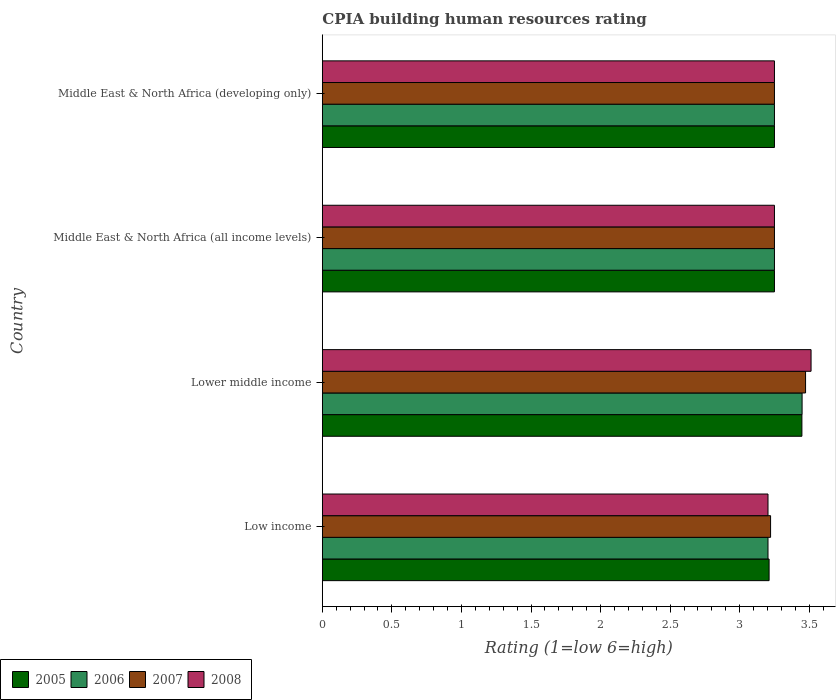How many different coloured bars are there?
Make the answer very short. 4. How many groups of bars are there?
Keep it short and to the point. 4. Are the number of bars per tick equal to the number of legend labels?
Your response must be concise. Yes. Are the number of bars on each tick of the Y-axis equal?
Ensure brevity in your answer.  Yes. How many bars are there on the 1st tick from the top?
Offer a terse response. 4. What is the label of the 1st group of bars from the top?
Your answer should be very brief. Middle East & North Africa (developing only). Across all countries, what is the maximum CPIA rating in 2007?
Your answer should be compact. 3.47. Across all countries, what is the minimum CPIA rating in 2007?
Make the answer very short. 3.22. In which country was the CPIA rating in 2006 maximum?
Your answer should be very brief. Lower middle income. In which country was the CPIA rating in 2008 minimum?
Provide a succinct answer. Low income. What is the total CPIA rating in 2005 in the graph?
Provide a short and direct response. 13.16. What is the difference between the CPIA rating in 2007 in Lower middle income and that in Middle East & North Africa (developing only)?
Offer a very short reply. 0.22. What is the difference between the CPIA rating in 2007 in Middle East & North Africa (all income levels) and the CPIA rating in 2006 in Low income?
Offer a very short reply. 0.05. What is the average CPIA rating in 2007 per country?
Keep it short and to the point. 3.3. What is the difference between the CPIA rating in 2006 and CPIA rating in 2007 in Middle East & North Africa (developing only)?
Provide a short and direct response. 0. In how many countries, is the CPIA rating in 2007 greater than 0.6 ?
Your answer should be compact. 4. What is the ratio of the CPIA rating in 2005 in Lower middle income to that in Middle East & North Africa (developing only)?
Provide a short and direct response. 1.06. Is the difference between the CPIA rating in 2006 in Low income and Middle East & North Africa (developing only) greater than the difference between the CPIA rating in 2007 in Low income and Middle East & North Africa (developing only)?
Provide a succinct answer. No. What is the difference between the highest and the second highest CPIA rating in 2005?
Offer a terse response. 0.2. What is the difference between the highest and the lowest CPIA rating in 2008?
Your response must be concise. 0.31. In how many countries, is the CPIA rating in 2007 greater than the average CPIA rating in 2007 taken over all countries?
Your response must be concise. 1. What does the 2nd bar from the top in Lower middle income represents?
Provide a succinct answer. 2007. Is it the case that in every country, the sum of the CPIA rating in 2008 and CPIA rating in 2006 is greater than the CPIA rating in 2005?
Offer a terse response. Yes. How many bars are there?
Ensure brevity in your answer.  16. What is the difference between two consecutive major ticks on the X-axis?
Provide a succinct answer. 0.5. Are the values on the major ticks of X-axis written in scientific E-notation?
Provide a succinct answer. No. Does the graph contain grids?
Make the answer very short. No. What is the title of the graph?
Your response must be concise. CPIA building human resources rating. Does "2009" appear as one of the legend labels in the graph?
Your response must be concise. No. What is the label or title of the X-axis?
Keep it short and to the point. Rating (1=low 6=high). What is the Rating (1=low 6=high) in 2005 in Low income?
Offer a terse response. 3.21. What is the Rating (1=low 6=high) of 2006 in Low income?
Provide a short and direct response. 3.2. What is the Rating (1=low 6=high) of 2007 in Low income?
Keep it short and to the point. 3.22. What is the Rating (1=low 6=high) in 2008 in Low income?
Offer a terse response. 3.2. What is the Rating (1=low 6=high) of 2005 in Lower middle income?
Offer a terse response. 3.45. What is the Rating (1=low 6=high) in 2006 in Lower middle income?
Offer a terse response. 3.45. What is the Rating (1=low 6=high) of 2007 in Lower middle income?
Offer a very short reply. 3.47. What is the Rating (1=low 6=high) in 2008 in Lower middle income?
Your response must be concise. 3.51. What is the Rating (1=low 6=high) of 2007 in Middle East & North Africa (developing only)?
Make the answer very short. 3.25. Across all countries, what is the maximum Rating (1=low 6=high) of 2005?
Provide a short and direct response. 3.45. Across all countries, what is the maximum Rating (1=low 6=high) in 2006?
Provide a short and direct response. 3.45. Across all countries, what is the maximum Rating (1=low 6=high) in 2007?
Offer a very short reply. 3.47. Across all countries, what is the maximum Rating (1=low 6=high) of 2008?
Your answer should be compact. 3.51. Across all countries, what is the minimum Rating (1=low 6=high) of 2005?
Keep it short and to the point. 3.21. Across all countries, what is the minimum Rating (1=low 6=high) in 2006?
Provide a succinct answer. 3.2. Across all countries, what is the minimum Rating (1=low 6=high) of 2007?
Ensure brevity in your answer.  3.22. Across all countries, what is the minimum Rating (1=low 6=high) in 2008?
Offer a terse response. 3.2. What is the total Rating (1=low 6=high) in 2005 in the graph?
Provide a short and direct response. 13.16. What is the total Rating (1=low 6=high) of 2006 in the graph?
Offer a terse response. 13.15. What is the total Rating (1=low 6=high) in 2007 in the graph?
Your answer should be compact. 13.2. What is the total Rating (1=low 6=high) of 2008 in the graph?
Your answer should be compact. 13.22. What is the difference between the Rating (1=low 6=high) of 2005 in Low income and that in Lower middle income?
Offer a terse response. -0.24. What is the difference between the Rating (1=low 6=high) of 2006 in Low income and that in Lower middle income?
Make the answer very short. -0.24. What is the difference between the Rating (1=low 6=high) of 2007 in Low income and that in Lower middle income?
Your answer should be compact. -0.25. What is the difference between the Rating (1=low 6=high) in 2008 in Low income and that in Lower middle income?
Give a very brief answer. -0.31. What is the difference between the Rating (1=low 6=high) in 2005 in Low income and that in Middle East & North Africa (all income levels)?
Your response must be concise. -0.04. What is the difference between the Rating (1=low 6=high) in 2006 in Low income and that in Middle East & North Africa (all income levels)?
Make the answer very short. -0.05. What is the difference between the Rating (1=low 6=high) in 2007 in Low income and that in Middle East & North Africa (all income levels)?
Your answer should be compact. -0.03. What is the difference between the Rating (1=low 6=high) of 2008 in Low income and that in Middle East & North Africa (all income levels)?
Provide a succinct answer. -0.05. What is the difference between the Rating (1=low 6=high) in 2005 in Low income and that in Middle East & North Africa (developing only)?
Your answer should be compact. -0.04. What is the difference between the Rating (1=low 6=high) of 2006 in Low income and that in Middle East & North Africa (developing only)?
Provide a short and direct response. -0.05. What is the difference between the Rating (1=low 6=high) in 2007 in Low income and that in Middle East & North Africa (developing only)?
Ensure brevity in your answer.  -0.03. What is the difference between the Rating (1=low 6=high) of 2008 in Low income and that in Middle East & North Africa (developing only)?
Your answer should be very brief. -0.05. What is the difference between the Rating (1=low 6=high) of 2005 in Lower middle income and that in Middle East & North Africa (all income levels)?
Your answer should be very brief. 0.2. What is the difference between the Rating (1=low 6=high) of 2006 in Lower middle income and that in Middle East & North Africa (all income levels)?
Your answer should be very brief. 0.2. What is the difference between the Rating (1=low 6=high) of 2007 in Lower middle income and that in Middle East & North Africa (all income levels)?
Your response must be concise. 0.22. What is the difference between the Rating (1=low 6=high) of 2008 in Lower middle income and that in Middle East & North Africa (all income levels)?
Offer a terse response. 0.26. What is the difference between the Rating (1=low 6=high) of 2005 in Lower middle income and that in Middle East & North Africa (developing only)?
Offer a terse response. 0.2. What is the difference between the Rating (1=low 6=high) of 2006 in Lower middle income and that in Middle East & North Africa (developing only)?
Your answer should be very brief. 0.2. What is the difference between the Rating (1=low 6=high) in 2007 in Lower middle income and that in Middle East & North Africa (developing only)?
Give a very brief answer. 0.22. What is the difference between the Rating (1=low 6=high) of 2008 in Lower middle income and that in Middle East & North Africa (developing only)?
Keep it short and to the point. 0.26. What is the difference between the Rating (1=low 6=high) of 2005 in Middle East & North Africa (all income levels) and that in Middle East & North Africa (developing only)?
Provide a succinct answer. 0. What is the difference between the Rating (1=low 6=high) of 2006 in Middle East & North Africa (all income levels) and that in Middle East & North Africa (developing only)?
Your answer should be very brief. 0. What is the difference between the Rating (1=low 6=high) in 2007 in Middle East & North Africa (all income levels) and that in Middle East & North Africa (developing only)?
Give a very brief answer. 0. What is the difference between the Rating (1=low 6=high) in 2005 in Low income and the Rating (1=low 6=high) in 2006 in Lower middle income?
Your answer should be very brief. -0.24. What is the difference between the Rating (1=low 6=high) in 2005 in Low income and the Rating (1=low 6=high) in 2007 in Lower middle income?
Provide a succinct answer. -0.26. What is the difference between the Rating (1=low 6=high) of 2005 in Low income and the Rating (1=low 6=high) of 2008 in Lower middle income?
Your response must be concise. -0.3. What is the difference between the Rating (1=low 6=high) of 2006 in Low income and the Rating (1=low 6=high) of 2007 in Lower middle income?
Offer a terse response. -0.27. What is the difference between the Rating (1=low 6=high) in 2006 in Low income and the Rating (1=low 6=high) in 2008 in Lower middle income?
Keep it short and to the point. -0.31. What is the difference between the Rating (1=low 6=high) of 2007 in Low income and the Rating (1=low 6=high) of 2008 in Lower middle income?
Provide a short and direct response. -0.29. What is the difference between the Rating (1=low 6=high) in 2005 in Low income and the Rating (1=low 6=high) in 2006 in Middle East & North Africa (all income levels)?
Make the answer very short. -0.04. What is the difference between the Rating (1=low 6=high) in 2005 in Low income and the Rating (1=low 6=high) in 2007 in Middle East & North Africa (all income levels)?
Your answer should be compact. -0.04. What is the difference between the Rating (1=low 6=high) of 2005 in Low income and the Rating (1=low 6=high) of 2008 in Middle East & North Africa (all income levels)?
Your answer should be very brief. -0.04. What is the difference between the Rating (1=low 6=high) of 2006 in Low income and the Rating (1=low 6=high) of 2007 in Middle East & North Africa (all income levels)?
Offer a very short reply. -0.05. What is the difference between the Rating (1=low 6=high) in 2006 in Low income and the Rating (1=low 6=high) in 2008 in Middle East & North Africa (all income levels)?
Your answer should be compact. -0.05. What is the difference between the Rating (1=low 6=high) in 2007 in Low income and the Rating (1=low 6=high) in 2008 in Middle East & North Africa (all income levels)?
Make the answer very short. -0.03. What is the difference between the Rating (1=low 6=high) in 2005 in Low income and the Rating (1=low 6=high) in 2006 in Middle East & North Africa (developing only)?
Provide a succinct answer. -0.04. What is the difference between the Rating (1=low 6=high) of 2005 in Low income and the Rating (1=low 6=high) of 2007 in Middle East & North Africa (developing only)?
Your response must be concise. -0.04. What is the difference between the Rating (1=low 6=high) of 2005 in Low income and the Rating (1=low 6=high) of 2008 in Middle East & North Africa (developing only)?
Provide a short and direct response. -0.04. What is the difference between the Rating (1=low 6=high) in 2006 in Low income and the Rating (1=low 6=high) in 2007 in Middle East & North Africa (developing only)?
Your response must be concise. -0.05. What is the difference between the Rating (1=low 6=high) in 2006 in Low income and the Rating (1=low 6=high) in 2008 in Middle East & North Africa (developing only)?
Ensure brevity in your answer.  -0.05. What is the difference between the Rating (1=low 6=high) of 2007 in Low income and the Rating (1=low 6=high) of 2008 in Middle East & North Africa (developing only)?
Offer a very short reply. -0.03. What is the difference between the Rating (1=low 6=high) of 2005 in Lower middle income and the Rating (1=low 6=high) of 2006 in Middle East & North Africa (all income levels)?
Provide a short and direct response. 0.2. What is the difference between the Rating (1=low 6=high) in 2005 in Lower middle income and the Rating (1=low 6=high) in 2007 in Middle East & North Africa (all income levels)?
Your answer should be very brief. 0.2. What is the difference between the Rating (1=low 6=high) in 2005 in Lower middle income and the Rating (1=low 6=high) in 2008 in Middle East & North Africa (all income levels)?
Provide a succinct answer. 0.2. What is the difference between the Rating (1=low 6=high) of 2006 in Lower middle income and the Rating (1=low 6=high) of 2007 in Middle East & North Africa (all income levels)?
Make the answer very short. 0.2. What is the difference between the Rating (1=low 6=high) in 2006 in Lower middle income and the Rating (1=low 6=high) in 2008 in Middle East & North Africa (all income levels)?
Your response must be concise. 0.2. What is the difference between the Rating (1=low 6=high) in 2007 in Lower middle income and the Rating (1=low 6=high) in 2008 in Middle East & North Africa (all income levels)?
Your answer should be compact. 0.22. What is the difference between the Rating (1=low 6=high) of 2005 in Lower middle income and the Rating (1=low 6=high) of 2006 in Middle East & North Africa (developing only)?
Your answer should be very brief. 0.2. What is the difference between the Rating (1=low 6=high) in 2005 in Lower middle income and the Rating (1=low 6=high) in 2007 in Middle East & North Africa (developing only)?
Offer a terse response. 0.2. What is the difference between the Rating (1=low 6=high) of 2005 in Lower middle income and the Rating (1=low 6=high) of 2008 in Middle East & North Africa (developing only)?
Ensure brevity in your answer.  0.2. What is the difference between the Rating (1=low 6=high) of 2006 in Lower middle income and the Rating (1=low 6=high) of 2007 in Middle East & North Africa (developing only)?
Offer a very short reply. 0.2. What is the difference between the Rating (1=low 6=high) of 2006 in Lower middle income and the Rating (1=low 6=high) of 2008 in Middle East & North Africa (developing only)?
Provide a succinct answer. 0.2. What is the difference between the Rating (1=low 6=high) of 2007 in Lower middle income and the Rating (1=low 6=high) of 2008 in Middle East & North Africa (developing only)?
Your response must be concise. 0.22. What is the difference between the Rating (1=low 6=high) of 2005 in Middle East & North Africa (all income levels) and the Rating (1=low 6=high) of 2006 in Middle East & North Africa (developing only)?
Make the answer very short. 0. What is the difference between the Rating (1=low 6=high) of 2007 in Middle East & North Africa (all income levels) and the Rating (1=low 6=high) of 2008 in Middle East & North Africa (developing only)?
Your answer should be compact. 0. What is the average Rating (1=low 6=high) of 2005 per country?
Your answer should be very brief. 3.29. What is the average Rating (1=low 6=high) of 2006 per country?
Your answer should be compact. 3.29. What is the average Rating (1=low 6=high) of 2007 per country?
Keep it short and to the point. 3.3. What is the average Rating (1=low 6=high) of 2008 per country?
Your answer should be very brief. 3.3. What is the difference between the Rating (1=low 6=high) in 2005 and Rating (1=low 6=high) in 2006 in Low income?
Your answer should be very brief. 0.01. What is the difference between the Rating (1=low 6=high) of 2005 and Rating (1=low 6=high) of 2007 in Low income?
Your answer should be very brief. -0.01. What is the difference between the Rating (1=low 6=high) of 2005 and Rating (1=low 6=high) of 2008 in Low income?
Keep it short and to the point. 0.01. What is the difference between the Rating (1=low 6=high) of 2006 and Rating (1=low 6=high) of 2007 in Low income?
Your answer should be very brief. -0.02. What is the difference between the Rating (1=low 6=high) of 2007 and Rating (1=low 6=high) of 2008 in Low income?
Ensure brevity in your answer.  0.02. What is the difference between the Rating (1=low 6=high) in 2005 and Rating (1=low 6=high) in 2006 in Lower middle income?
Ensure brevity in your answer.  -0. What is the difference between the Rating (1=low 6=high) in 2005 and Rating (1=low 6=high) in 2007 in Lower middle income?
Your response must be concise. -0.03. What is the difference between the Rating (1=low 6=high) in 2005 and Rating (1=low 6=high) in 2008 in Lower middle income?
Your answer should be compact. -0.07. What is the difference between the Rating (1=low 6=high) in 2006 and Rating (1=low 6=high) in 2007 in Lower middle income?
Provide a succinct answer. -0.03. What is the difference between the Rating (1=low 6=high) of 2006 and Rating (1=low 6=high) of 2008 in Lower middle income?
Your response must be concise. -0.06. What is the difference between the Rating (1=low 6=high) in 2007 and Rating (1=low 6=high) in 2008 in Lower middle income?
Your answer should be compact. -0.04. What is the difference between the Rating (1=low 6=high) of 2005 and Rating (1=low 6=high) of 2007 in Middle East & North Africa (all income levels)?
Offer a terse response. 0. What is the difference between the Rating (1=low 6=high) of 2005 and Rating (1=low 6=high) of 2008 in Middle East & North Africa (all income levels)?
Keep it short and to the point. 0. What is the difference between the Rating (1=low 6=high) in 2006 and Rating (1=low 6=high) in 2007 in Middle East & North Africa (all income levels)?
Keep it short and to the point. 0. What is the difference between the Rating (1=low 6=high) in 2007 and Rating (1=low 6=high) in 2008 in Middle East & North Africa (all income levels)?
Give a very brief answer. 0. What is the difference between the Rating (1=low 6=high) of 2005 and Rating (1=low 6=high) of 2007 in Middle East & North Africa (developing only)?
Offer a very short reply. 0. What is the difference between the Rating (1=low 6=high) in 2005 and Rating (1=low 6=high) in 2008 in Middle East & North Africa (developing only)?
Give a very brief answer. 0. What is the difference between the Rating (1=low 6=high) of 2006 and Rating (1=low 6=high) of 2007 in Middle East & North Africa (developing only)?
Your answer should be compact. 0. What is the difference between the Rating (1=low 6=high) of 2007 and Rating (1=low 6=high) of 2008 in Middle East & North Africa (developing only)?
Keep it short and to the point. 0. What is the ratio of the Rating (1=low 6=high) of 2005 in Low income to that in Lower middle income?
Offer a very short reply. 0.93. What is the ratio of the Rating (1=low 6=high) of 2006 in Low income to that in Lower middle income?
Provide a succinct answer. 0.93. What is the ratio of the Rating (1=low 6=high) in 2007 in Low income to that in Lower middle income?
Offer a terse response. 0.93. What is the ratio of the Rating (1=low 6=high) in 2008 in Low income to that in Lower middle income?
Your response must be concise. 0.91. What is the ratio of the Rating (1=low 6=high) in 2006 in Low income to that in Middle East & North Africa (all income levels)?
Ensure brevity in your answer.  0.99. What is the ratio of the Rating (1=low 6=high) in 2007 in Low income to that in Middle East & North Africa (all income levels)?
Provide a succinct answer. 0.99. What is the ratio of the Rating (1=low 6=high) of 2008 in Low income to that in Middle East & North Africa (all income levels)?
Provide a succinct answer. 0.99. What is the ratio of the Rating (1=low 6=high) in 2006 in Low income to that in Middle East & North Africa (developing only)?
Keep it short and to the point. 0.99. What is the ratio of the Rating (1=low 6=high) in 2007 in Low income to that in Middle East & North Africa (developing only)?
Provide a short and direct response. 0.99. What is the ratio of the Rating (1=low 6=high) in 2008 in Low income to that in Middle East & North Africa (developing only)?
Ensure brevity in your answer.  0.99. What is the ratio of the Rating (1=low 6=high) in 2005 in Lower middle income to that in Middle East & North Africa (all income levels)?
Offer a terse response. 1.06. What is the ratio of the Rating (1=low 6=high) in 2006 in Lower middle income to that in Middle East & North Africa (all income levels)?
Keep it short and to the point. 1.06. What is the ratio of the Rating (1=low 6=high) of 2007 in Lower middle income to that in Middle East & North Africa (all income levels)?
Offer a terse response. 1.07. What is the ratio of the Rating (1=low 6=high) of 2008 in Lower middle income to that in Middle East & North Africa (all income levels)?
Ensure brevity in your answer.  1.08. What is the ratio of the Rating (1=low 6=high) of 2005 in Lower middle income to that in Middle East & North Africa (developing only)?
Make the answer very short. 1.06. What is the ratio of the Rating (1=low 6=high) in 2006 in Lower middle income to that in Middle East & North Africa (developing only)?
Your answer should be compact. 1.06. What is the ratio of the Rating (1=low 6=high) of 2007 in Lower middle income to that in Middle East & North Africa (developing only)?
Provide a short and direct response. 1.07. What is the ratio of the Rating (1=low 6=high) in 2008 in Lower middle income to that in Middle East & North Africa (developing only)?
Make the answer very short. 1.08. What is the ratio of the Rating (1=low 6=high) of 2005 in Middle East & North Africa (all income levels) to that in Middle East & North Africa (developing only)?
Ensure brevity in your answer.  1. What is the ratio of the Rating (1=low 6=high) in 2006 in Middle East & North Africa (all income levels) to that in Middle East & North Africa (developing only)?
Provide a short and direct response. 1. What is the ratio of the Rating (1=low 6=high) of 2007 in Middle East & North Africa (all income levels) to that in Middle East & North Africa (developing only)?
Your response must be concise. 1. What is the ratio of the Rating (1=low 6=high) in 2008 in Middle East & North Africa (all income levels) to that in Middle East & North Africa (developing only)?
Your response must be concise. 1. What is the difference between the highest and the second highest Rating (1=low 6=high) in 2005?
Make the answer very short. 0.2. What is the difference between the highest and the second highest Rating (1=low 6=high) of 2006?
Your response must be concise. 0.2. What is the difference between the highest and the second highest Rating (1=low 6=high) of 2007?
Provide a short and direct response. 0.22. What is the difference between the highest and the second highest Rating (1=low 6=high) in 2008?
Your response must be concise. 0.26. What is the difference between the highest and the lowest Rating (1=low 6=high) of 2005?
Your answer should be very brief. 0.24. What is the difference between the highest and the lowest Rating (1=low 6=high) in 2006?
Give a very brief answer. 0.24. What is the difference between the highest and the lowest Rating (1=low 6=high) in 2007?
Ensure brevity in your answer.  0.25. What is the difference between the highest and the lowest Rating (1=low 6=high) of 2008?
Make the answer very short. 0.31. 